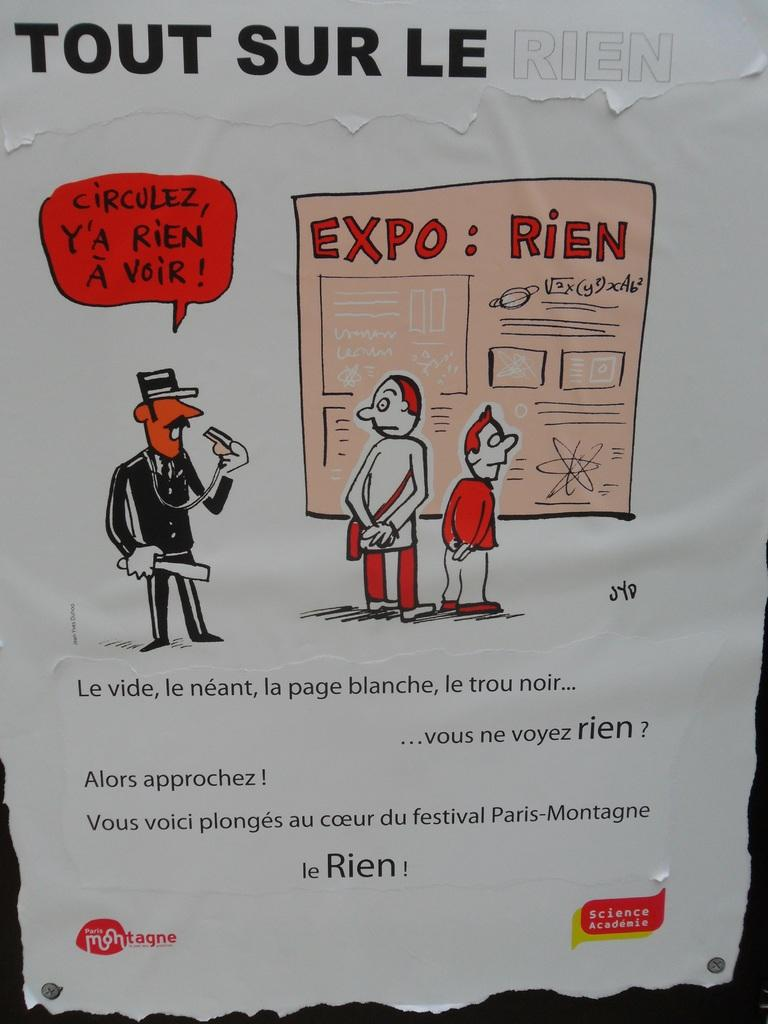What type of visual is the image? The image is a poster. What can be found on the poster besides the visuals? There is text on the poster. What is depicted on the poster in terms of visuals? There is a depiction of people on the poster. Where is the heart-shaped furniture located in the image? There is no heart-shaped furniture present in the image. How is the knot tied by the people depicted on the poster? There is no knot-tying activity depicted on the poster; it features a depiction of people. 